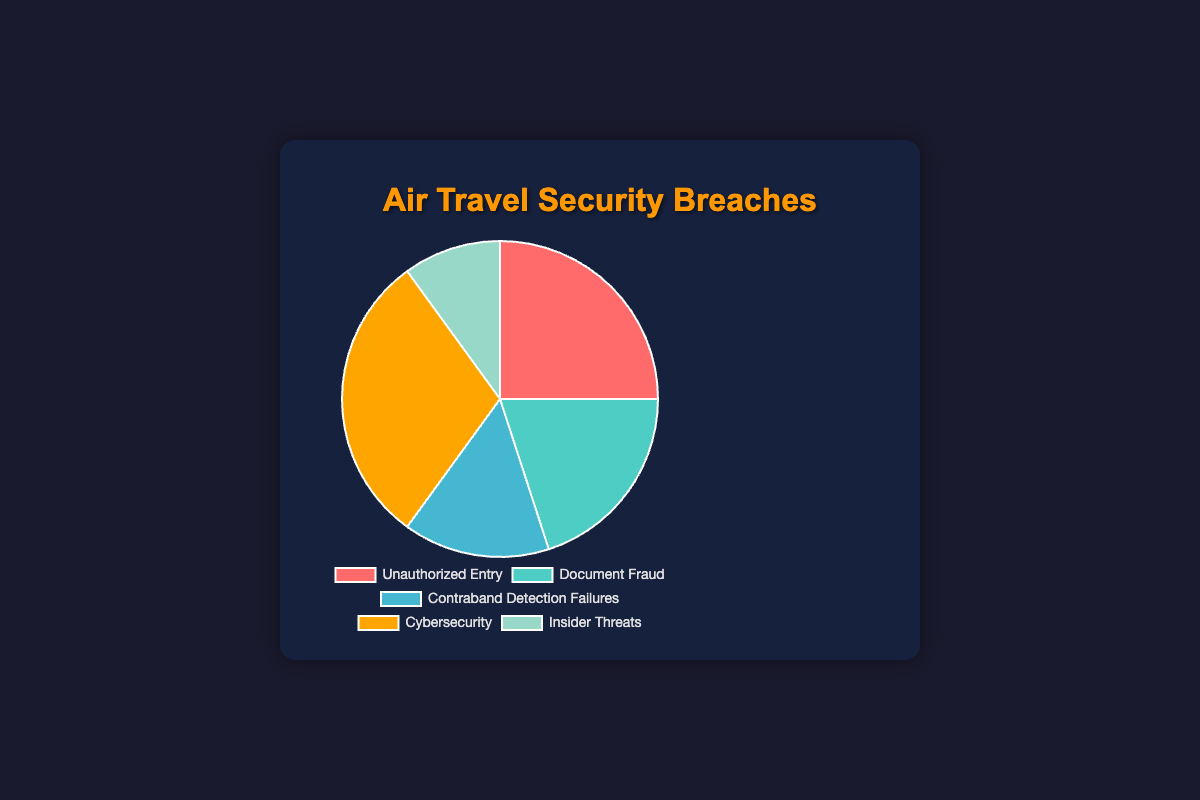What percentage of security breaches is attributed to Cybersecurity? Cybersecurity accounts for 30% of the security breaches as shown in the pie chart.
Answer: 30% Which method has the smallest portion of security breaches? Insider Threats is the smallest portion in the pie chart, accounting for only 10% of the security breaches.
Answer: Insider Threats Which two methods combined account for the largest percentage of security breaches? Adding the percentages of Unauthorized Entry (25%) and Cybersecurity (30%) results in a total of 55%, which is the largest combined percentage compared to other pairs.
Answer: Unauthorized Entry and Cybersecurity What is the total percentage of breaches caused by Unauthorized Entry, Document Fraud, and Contraband Detection Failures? The sum of Unauthorized Entry (25%), Document Fraud (20%), and Contraband Detection Failures (15%) is 25 + 20 + 15 = 60%.
Answer: 60% Which method of security breach is represented by the color orange in the pie chart? The orange segment in the pie chart represents Cybersecurity breaches.
Answer: Cybersecurity How much larger in percentage is Cybersecurity compared to Contraband Detection Failures? The percentage for Cybersecurity is 30% and for Contraband Detection Failures is 15%. The difference is 30% - 15% = 15%.
Answer: 15% If we treat Unauthorized Entry and Document Fraud as one combined category, how does its percentage compare to Cybersecurity? Adding Unauthorized Entry (25%) and Document Fraud (20%) gives a combined total of 45%, which is larger than the 30% for Cybersecurity.
Answer: Larger Which method has the second-highest occurrence of security breaches? Unauthorized Entry, which accounts for 25% of the security breaches, is the second-highest after Cybersecurity.
Answer: Unauthorized Entry What is the difference in percentage points between the highest and the lowest security breach categories? The highest breach percentage is Cybersecurity at 30%, and the lowest is Insider Threats at 10%. The difference is 30% - 10% = 20%.
Answer: 20% 